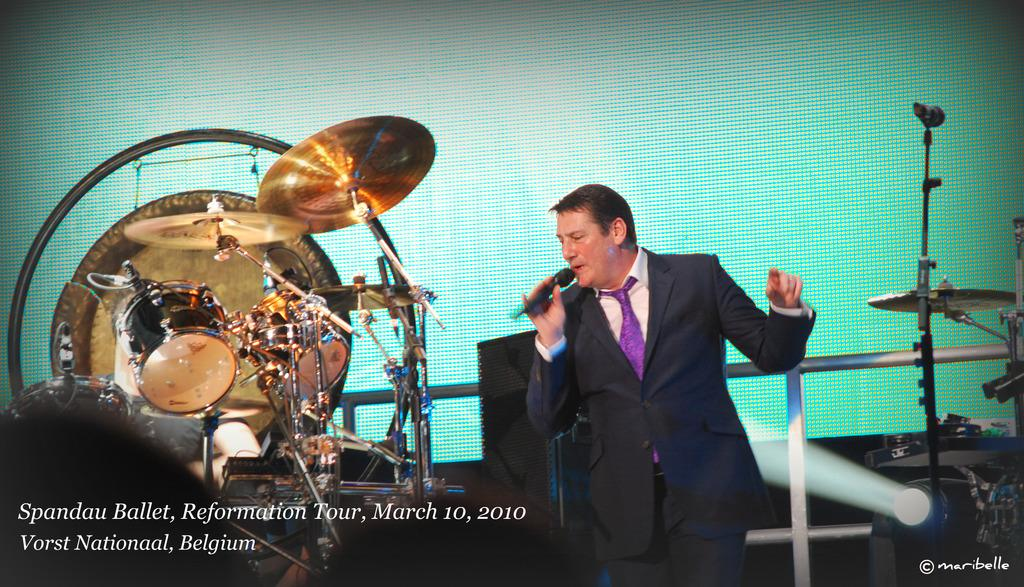What is the person in the image doing? The person is standing and holding a mic. What instrument is visible beside the person? There is a drum set beside the person. What can be seen in the image that provides illumination? There is a light visible in the image. What is located behind the person? There is a wall at the backside of the person. What type of powder is being used for the birthday celebration in the image? There is no birthday celebration or powder present in the image. What type of office equipment can be seen in the image? There is no office equipment present in the image. 